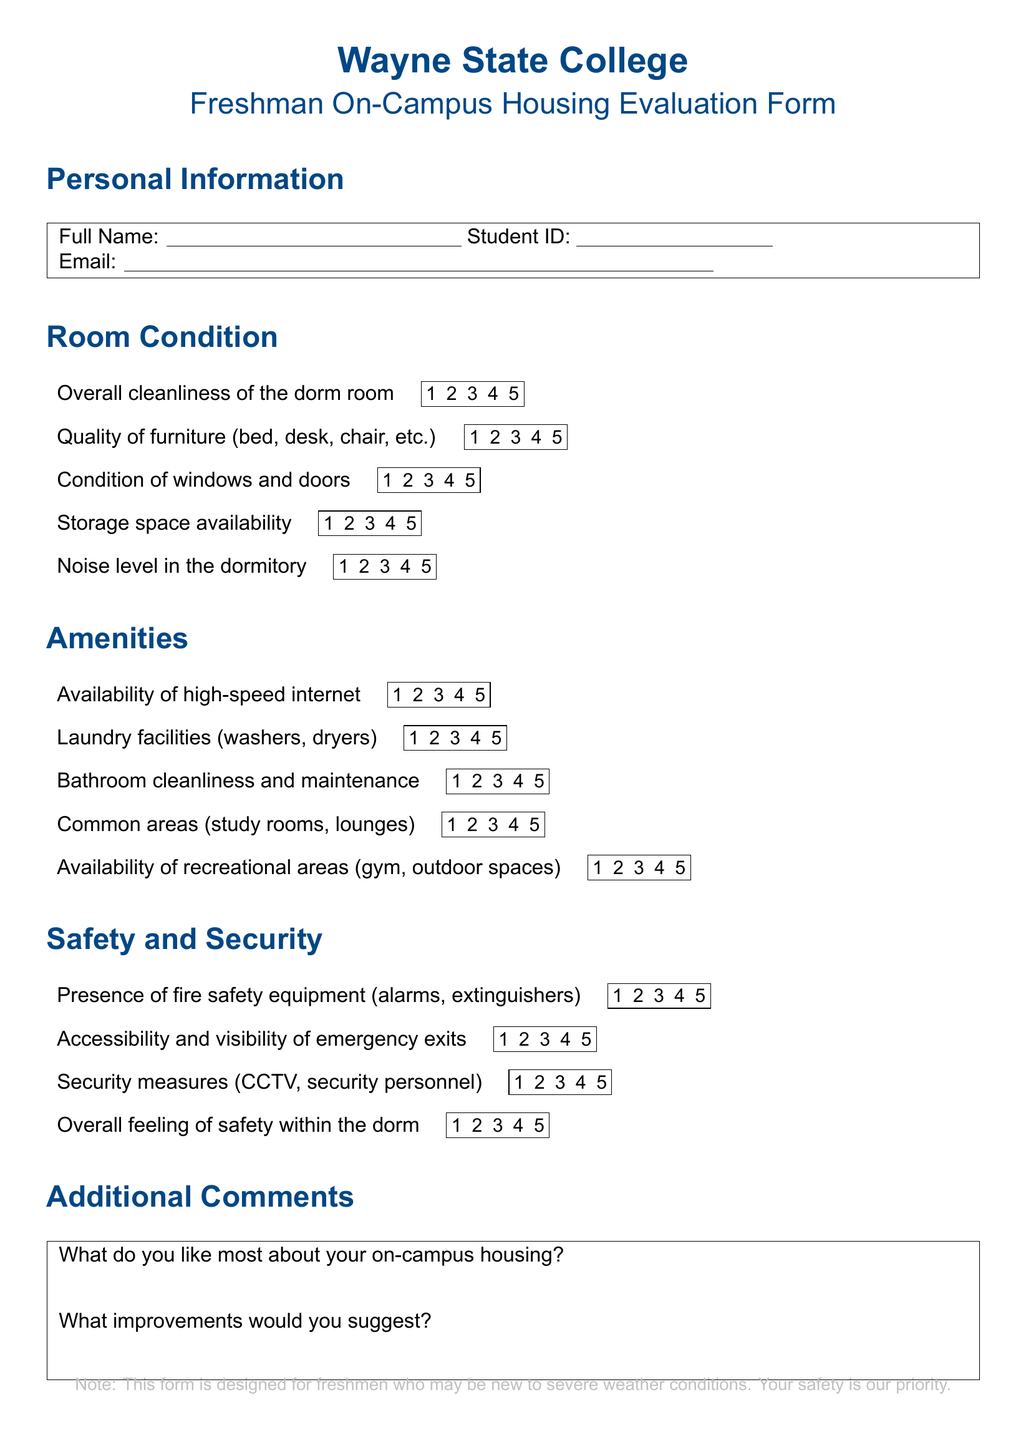What is the title of the document? The title can be found at the top of the document and indicates its purpose and subject matter.
Answer: Freshman On-Campus Housing Evaluation Form What is included under the Room Condition section? This section includes various aspects to evaluate the dorm room's condition, such as cleanliness and noise levels.
Answer: Overall cleanliness of the dorm room, Quality of furniture, Condition of windows and doors, Storage space availability, Noise level in the dormitory How many items are listed under Amenities? The Amenities section contains several items to evaluate the facilities provided in the dorms. Counting them gives the answer.
Answer: Five What color is the note at the bottom of the document? The note's color is indicated by the chosen color code in the document.
Answer: Tornadogray Which item assesses safety measures within the dorm? This asks for a specific item that evaluates safety in the housing context and is clearly defined in its section.
Answer: Security measures What type of feedback is requested in the Additional Comments section? The document specifies two types of feedback it seeks from the respondents under this section.
Answer: Likes and improvements How many safety-related items are there? By counting the items in the Safety and Security section, we find how many aspects of safety are being assessed.
Answer: Four What is the overall focus of the evaluation form? This question pertains to the general assessment purpose outlined throughout the document.
Answer: On-Campus Housing Conditions and Amenities 